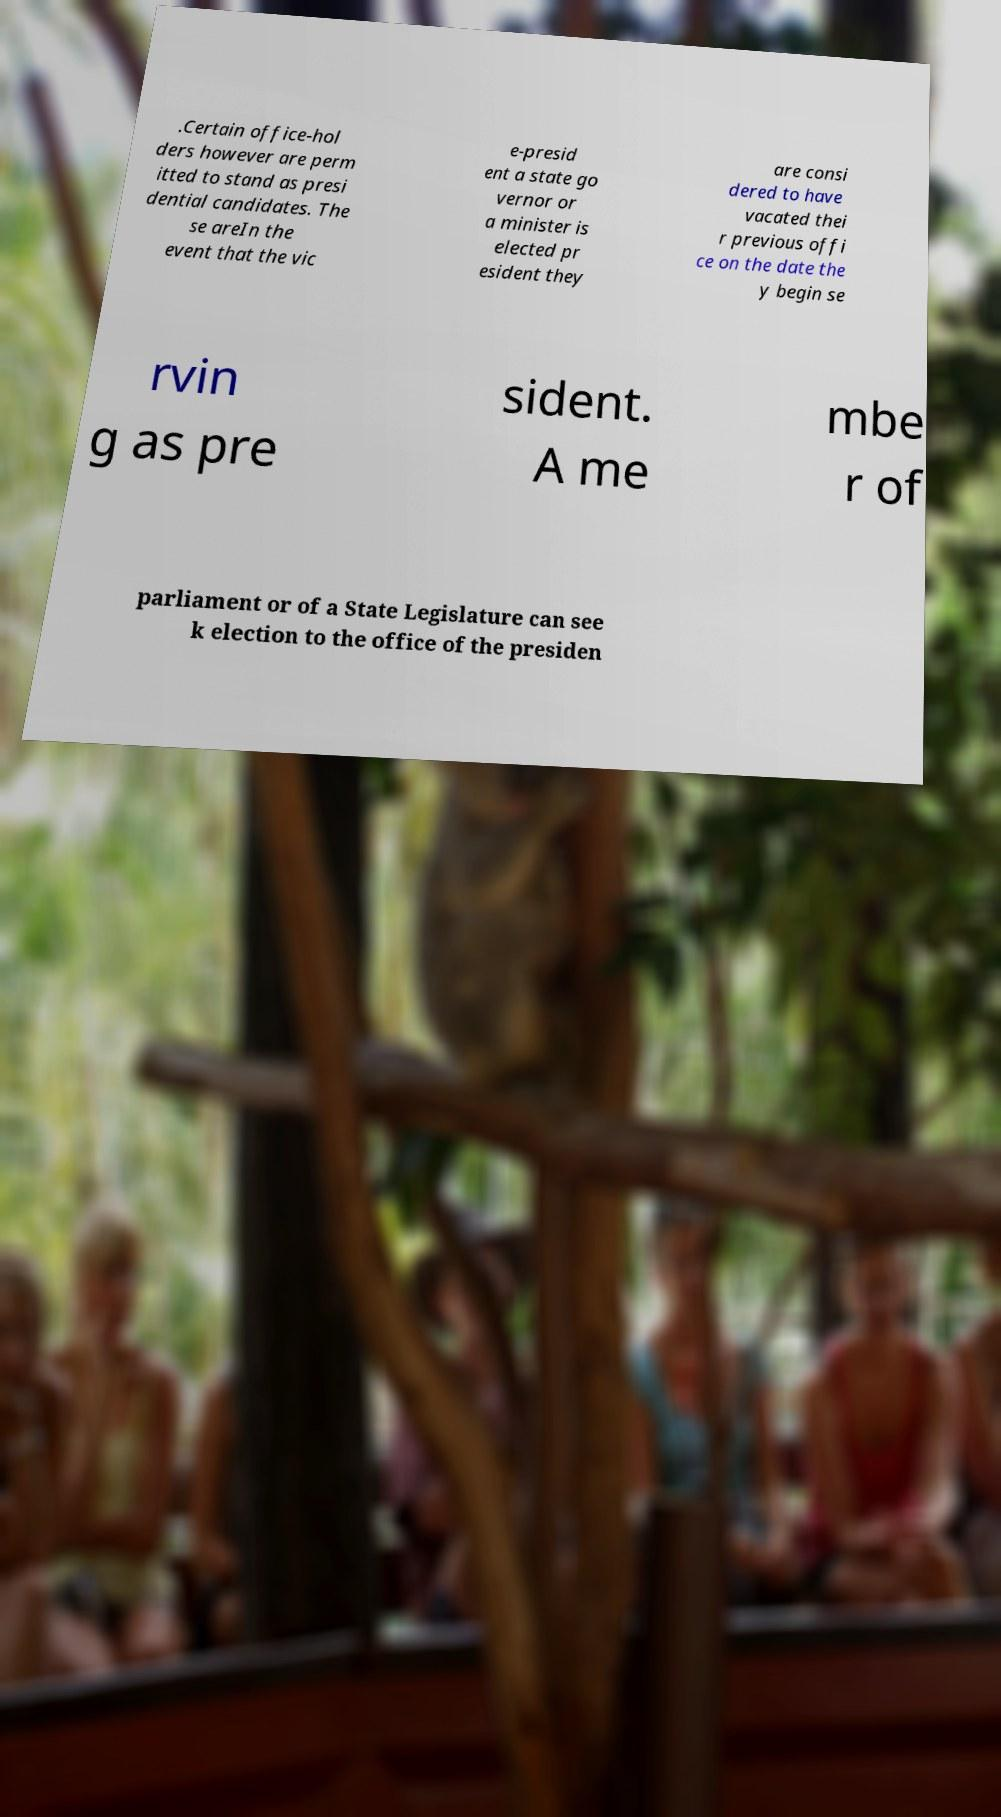For documentation purposes, I need the text within this image transcribed. Could you provide that? .Certain office-hol ders however are perm itted to stand as presi dential candidates. The se areIn the event that the vic e-presid ent a state go vernor or a minister is elected pr esident they are consi dered to have vacated thei r previous offi ce on the date the y begin se rvin g as pre sident. A me mbe r of parliament or of a State Legislature can see k election to the office of the presiden 